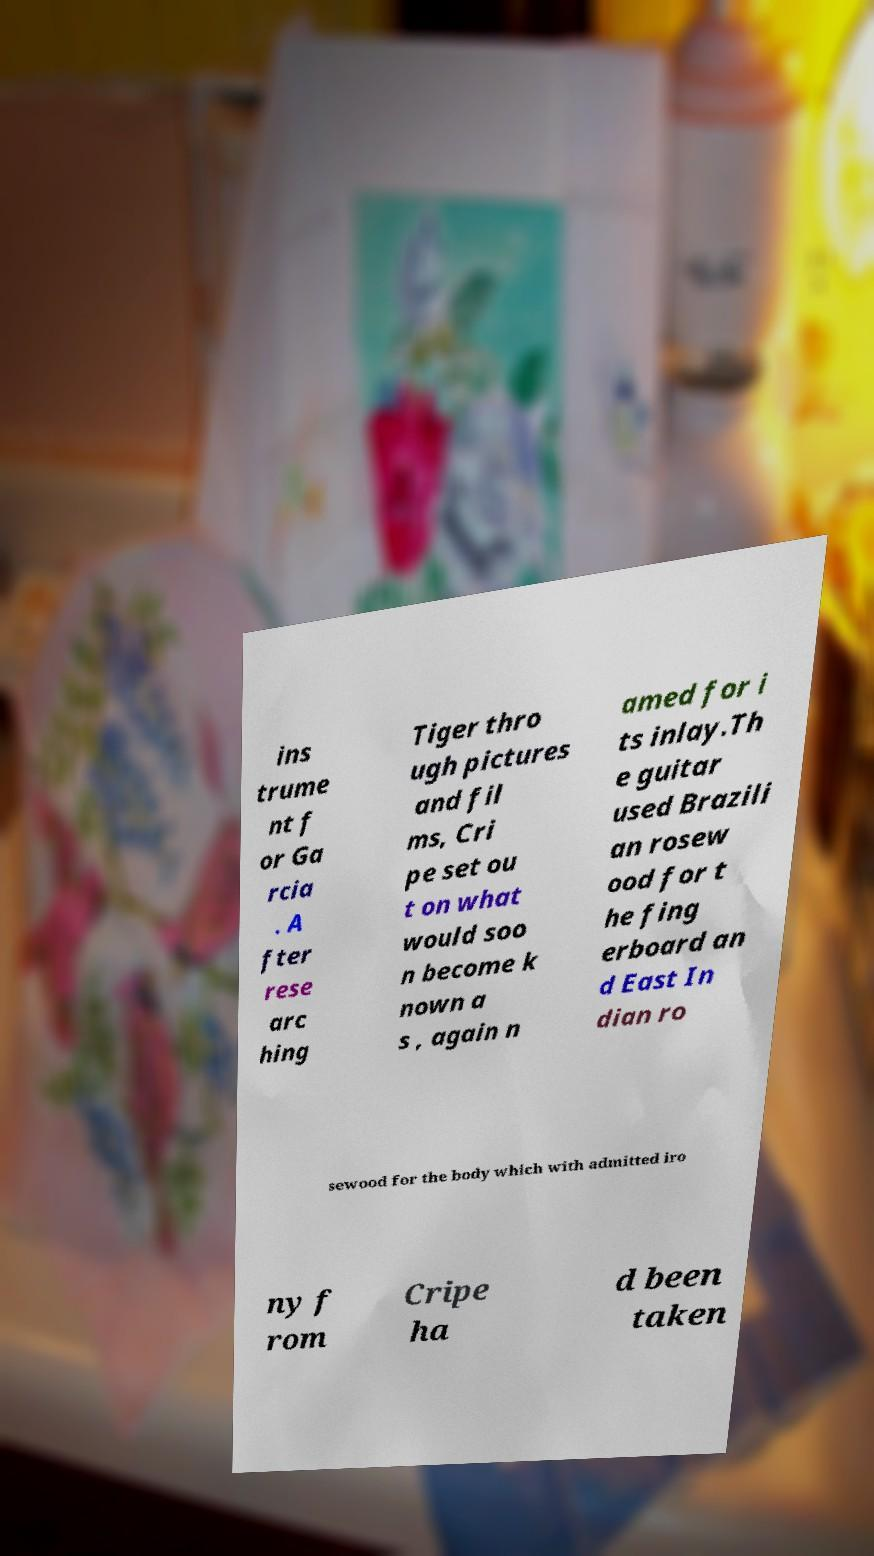For documentation purposes, I need the text within this image transcribed. Could you provide that? ins trume nt f or Ga rcia . A fter rese arc hing Tiger thro ugh pictures and fil ms, Cri pe set ou t on what would soo n become k nown a s , again n amed for i ts inlay.Th e guitar used Brazili an rosew ood for t he fing erboard an d East In dian ro sewood for the body which with admitted iro ny f rom Cripe ha d been taken 